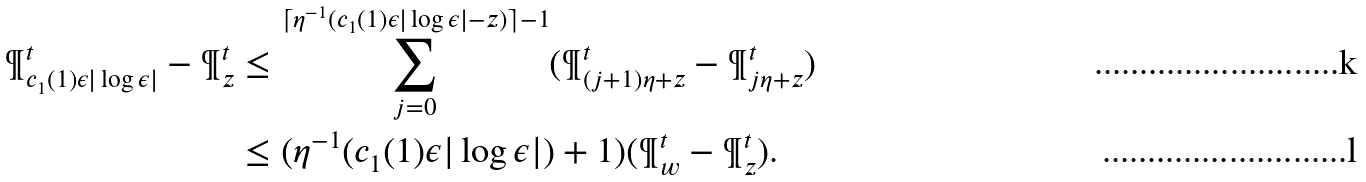<formula> <loc_0><loc_0><loc_500><loc_500>\P ^ { t } _ { c _ { 1 } ( 1 ) \epsilon | \log \epsilon | } - \P ^ { t } _ { z } & \leq \sum _ { j = 0 } ^ { \lceil \eta ^ { - 1 } ( c _ { 1 } ( 1 ) \epsilon | \log \epsilon | - z ) \rceil - 1 } ( \P ^ { t } _ { ( j + 1 ) \eta + z } - \P ^ { t } _ { j \eta + z } ) \\ & \leq ( \eta ^ { - 1 } ( c _ { 1 } ( 1 ) \epsilon | \log \epsilon | ) + 1 ) ( \P ^ { t } _ { w } - \P ^ { t } _ { z } ) .</formula> 